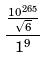<formula> <loc_0><loc_0><loc_500><loc_500>\frac { \frac { 1 0 ^ { 2 6 5 } } { \sqrt { 6 } } } { 1 ^ { 9 } }</formula> 